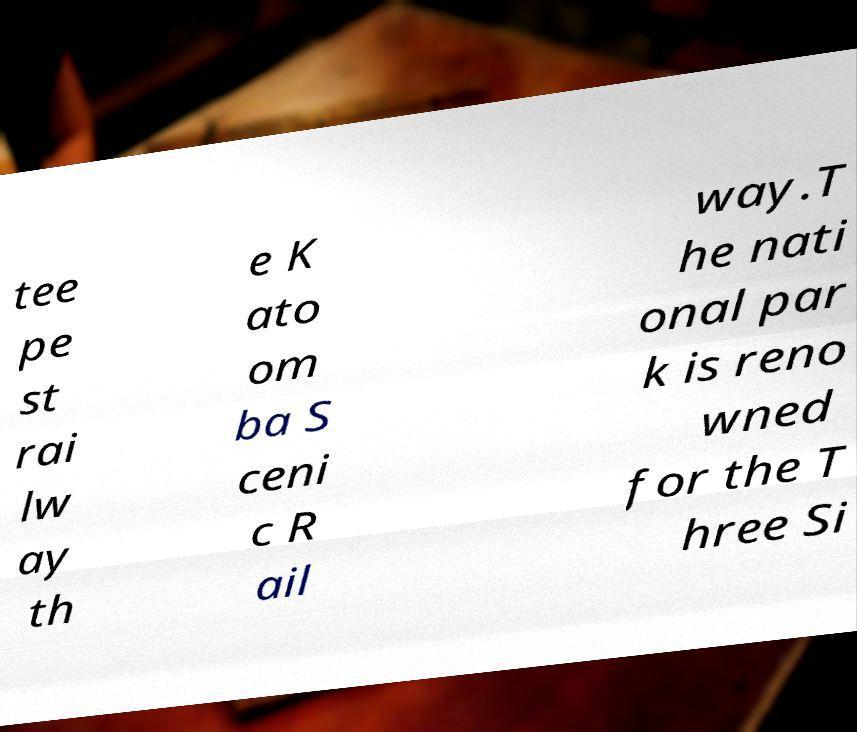Please read and relay the text visible in this image. What does it say? tee pe st rai lw ay th e K ato om ba S ceni c R ail way.T he nati onal par k is reno wned for the T hree Si 